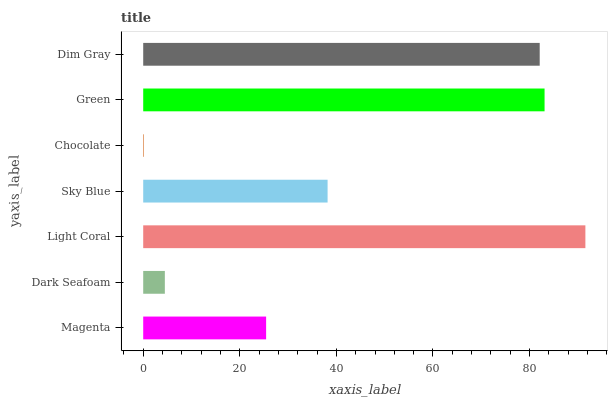Is Chocolate the minimum?
Answer yes or no. Yes. Is Light Coral the maximum?
Answer yes or no. Yes. Is Dark Seafoam the minimum?
Answer yes or no. No. Is Dark Seafoam the maximum?
Answer yes or no. No. Is Magenta greater than Dark Seafoam?
Answer yes or no. Yes. Is Dark Seafoam less than Magenta?
Answer yes or no. Yes. Is Dark Seafoam greater than Magenta?
Answer yes or no. No. Is Magenta less than Dark Seafoam?
Answer yes or no. No. Is Sky Blue the high median?
Answer yes or no. Yes. Is Sky Blue the low median?
Answer yes or no. Yes. Is Dim Gray the high median?
Answer yes or no. No. Is Dim Gray the low median?
Answer yes or no. No. 